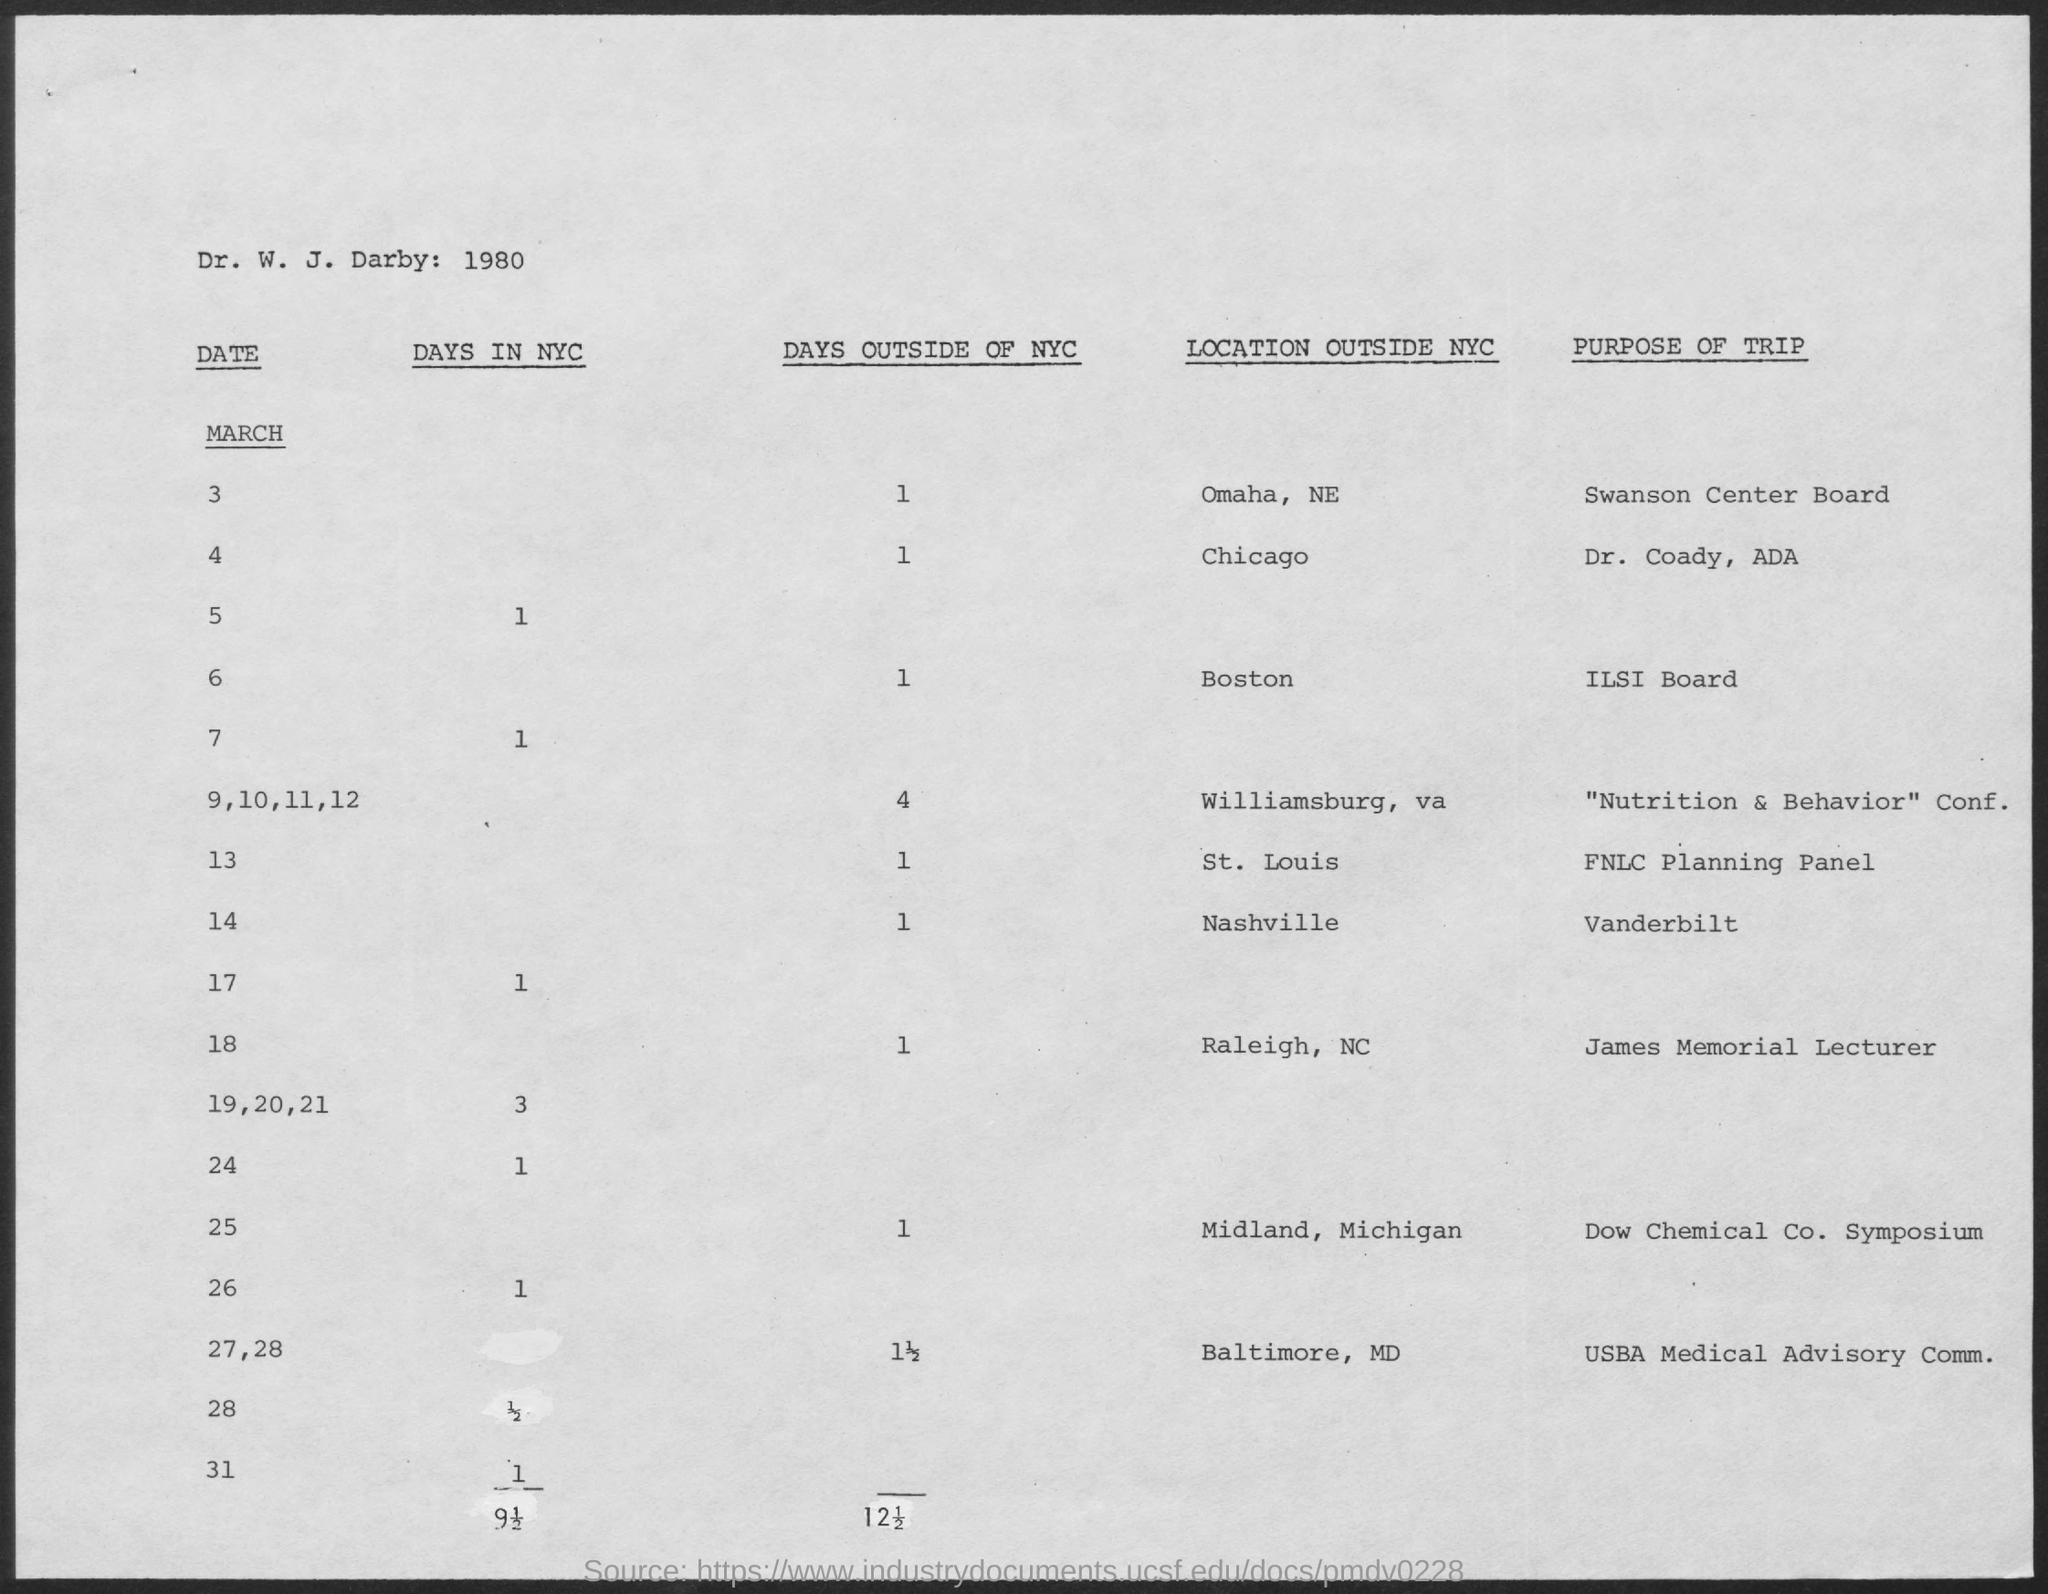What is the purpose of trip on March 18?
Keep it short and to the point. James Memorial Lecturer. 